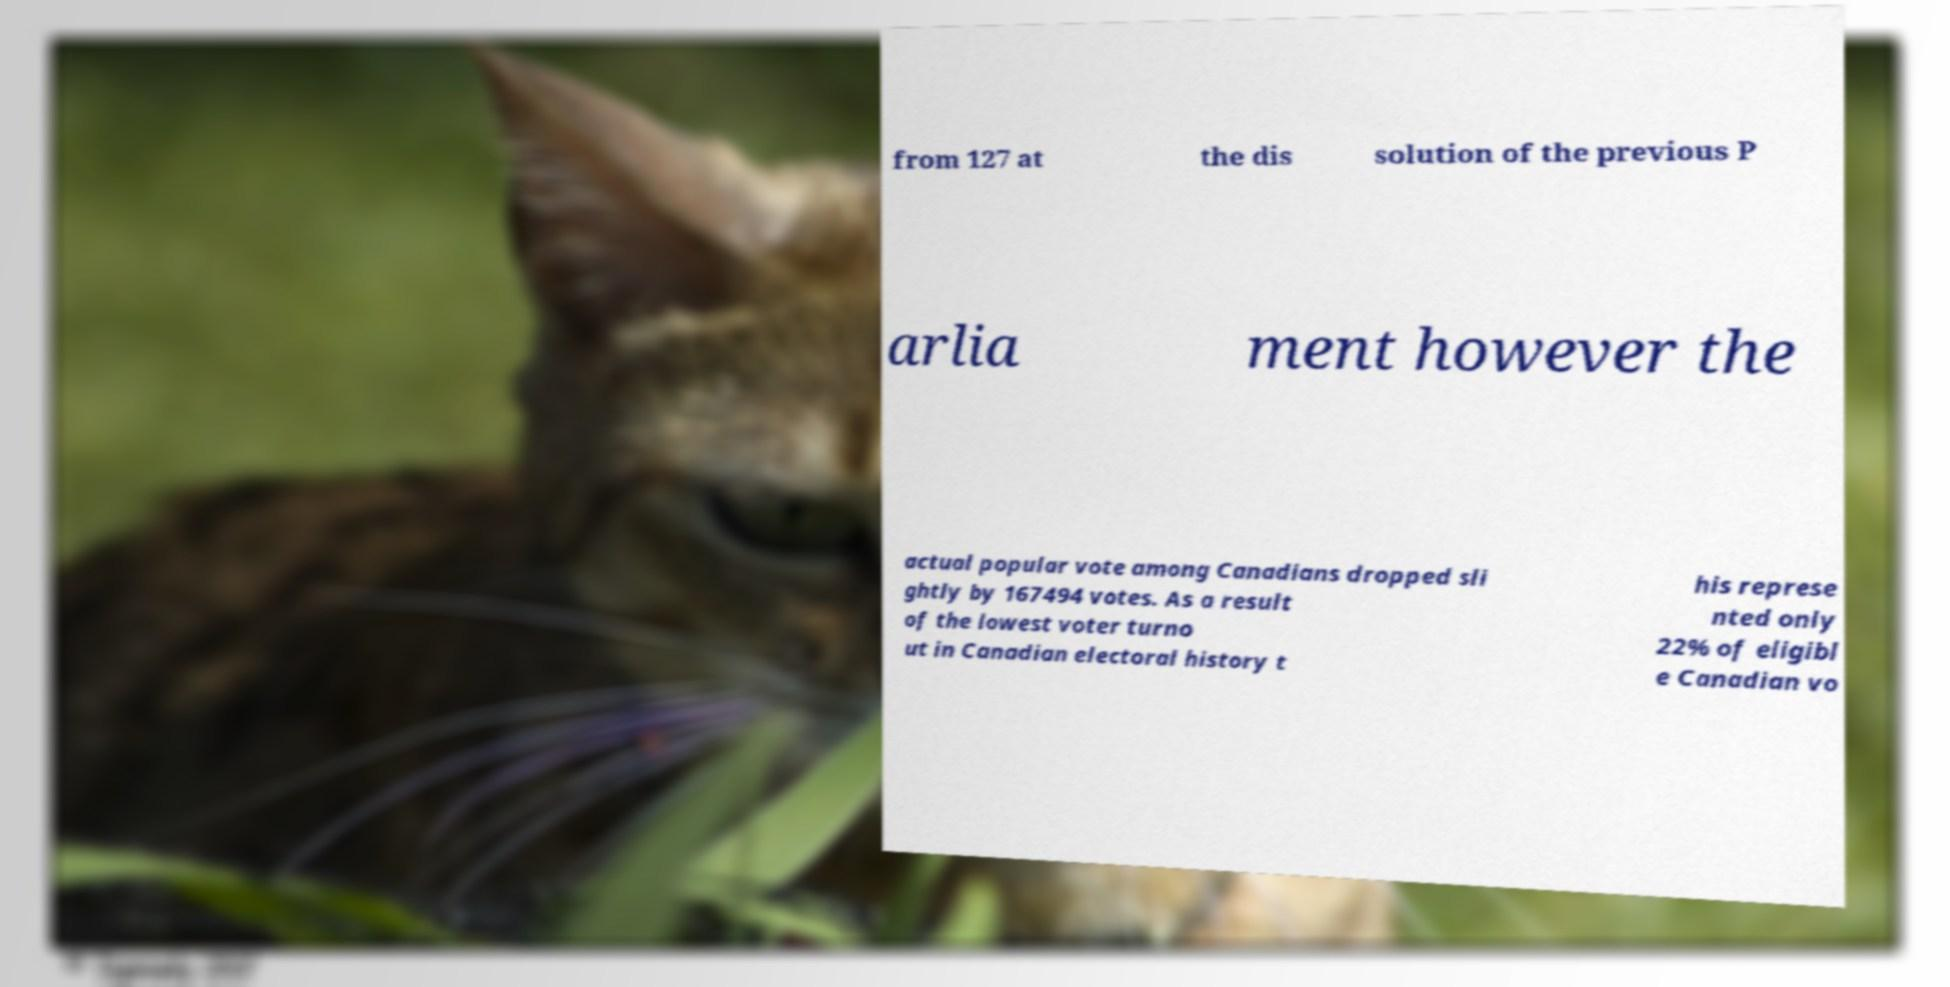I need the written content from this picture converted into text. Can you do that? from 127 at the dis solution of the previous P arlia ment however the actual popular vote among Canadians dropped sli ghtly by 167494 votes. As a result of the lowest voter turno ut in Canadian electoral history t his represe nted only 22% of eligibl e Canadian vo 